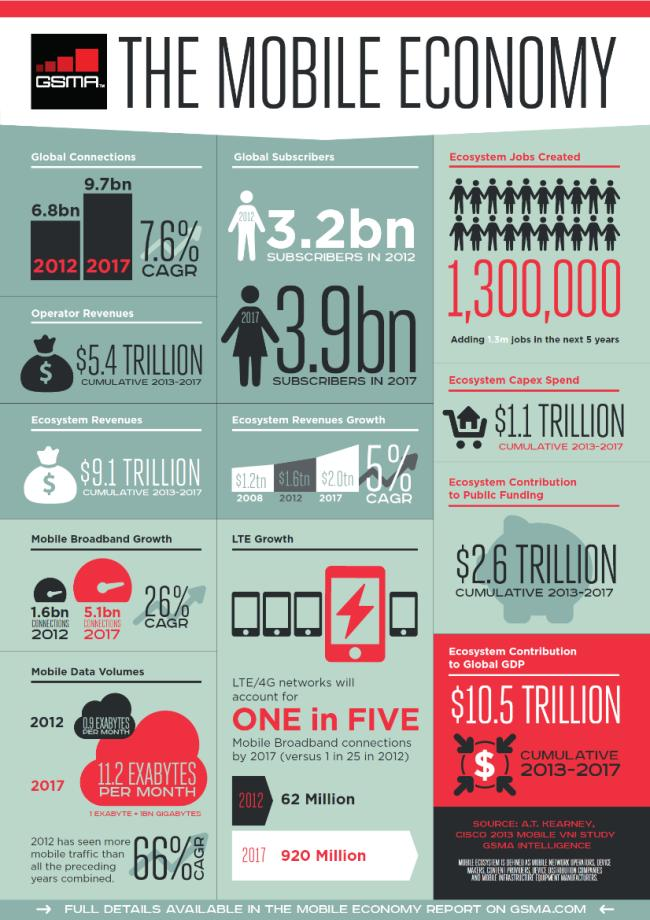Point out several critical features in this image. In 2017, there were approximately 5.1 billion broadband connections worldwide. The ecosystem revenues growth in 2012 was $1.6 trillion. In 2017, there were approximately 3.9 billion global subscribers. 